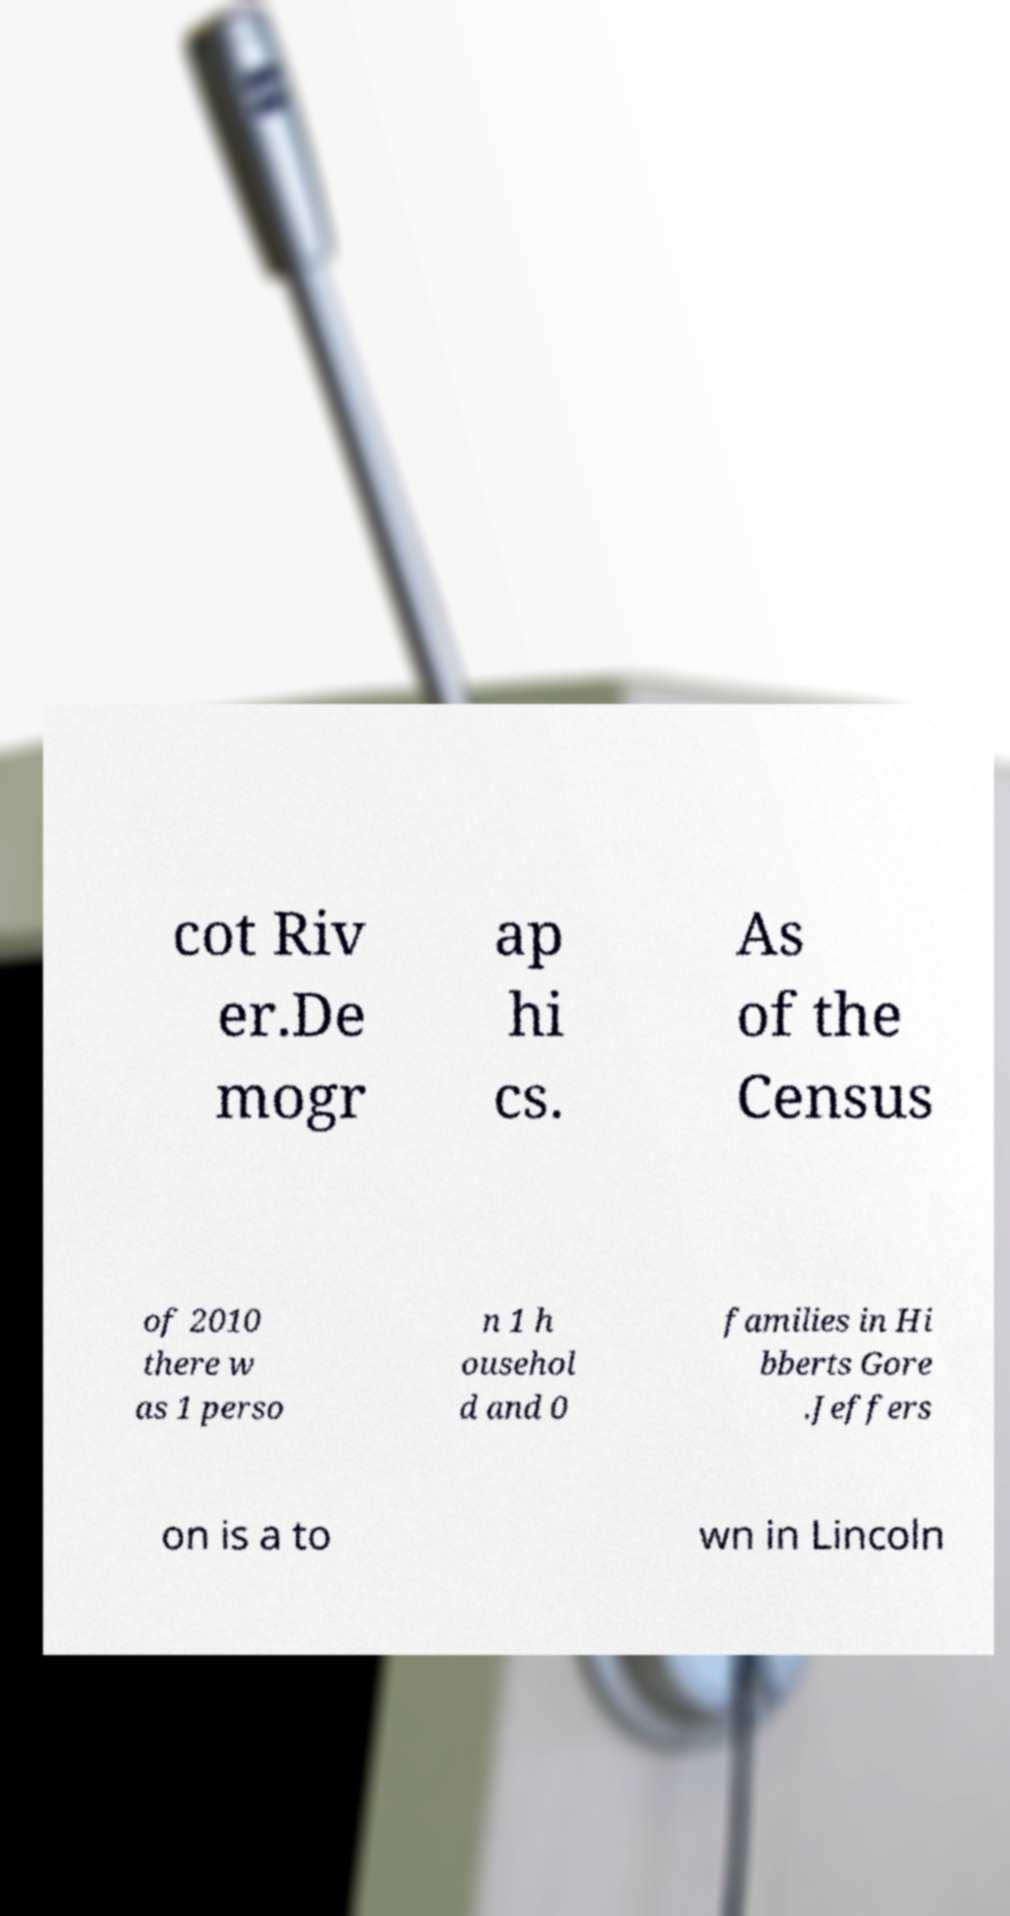Please read and relay the text visible in this image. What does it say? cot Riv er.De mogr ap hi cs. As of the Census of 2010 there w as 1 perso n 1 h ousehol d and 0 families in Hi bberts Gore .Jeffers on is a to wn in Lincoln 